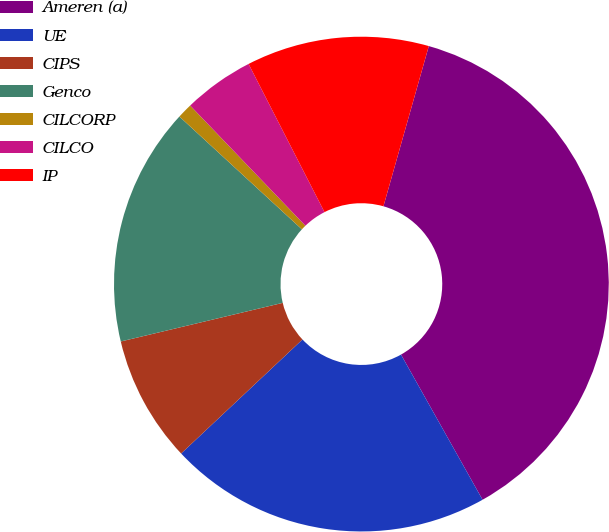Convert chart. <chart><loc_0><loc_0><loc_500><loc_500><pie_chart><fcel>Ameren (a)<fcel>UE<fcel>CIPS<fcel>Genco<fcel>CILCORP<fcel>CILCO<fcel>IP<nl><fcel>37.46%<fcel>21.14%<fcel>8.28%<fcel>15.57%<fcel>0.99%<fcel>4.63%<fcel>11.93%<nl></chart> 